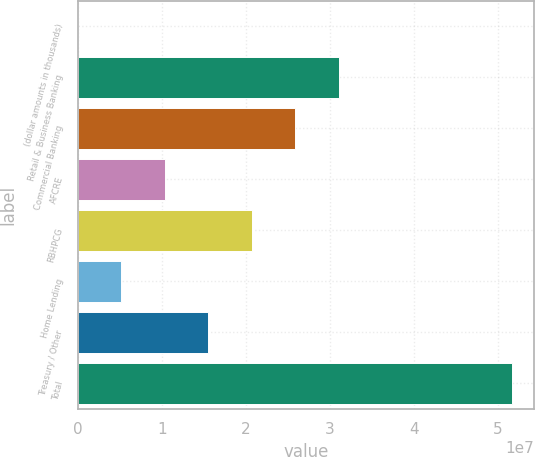Convert chart. <chart><loc_0><loc_0><loc_500><loc_500><bar_chart><fcel>(dollar amounts in thousands)<fcel>Retail & Business Banking<fcel>Commercial Banking<fcel>AFCRE<fcel>RBHPCG<fcel>Home Lending<fcel>Treasury / Other<fcel>Total<nl><fcel>2014<fcel>3.10401e+07<fcel>2.58671e+07<fcel>1.0348e+07<fcel>2.06941e+07<fcel>5.17503e+06<fcel>1.55211e+07<fcel>5.17322e+07<nl></chart> 